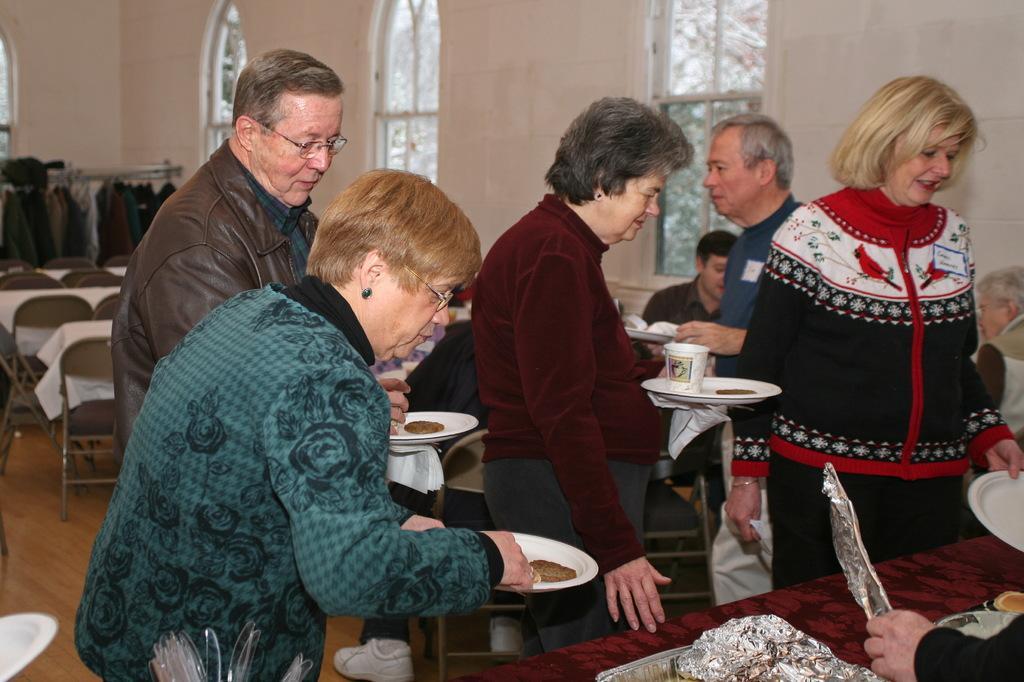In one or two sentences, can you explain what this image depicts? In this image in the center there are persons standing and sitting. In the front there is a woman standing and holding a plate. In the background there are chairs and there are tables and there are clothes hanging and there are windows. 